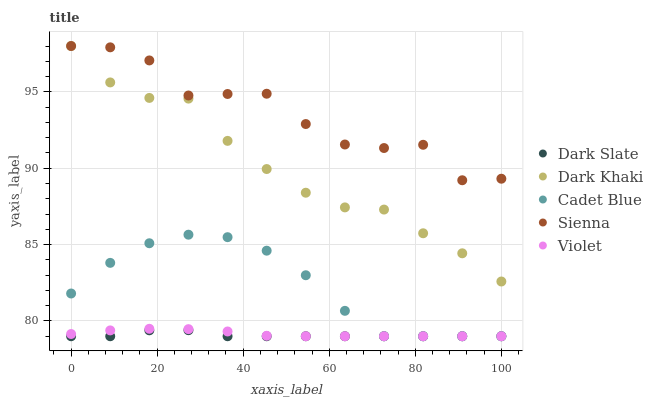Does Dark Slate have the minimum area under the curve?
Answer yes or no. Yes. Does Sienna have the maximum area under the curve?
Answer yes or no. Yes. Does Cadet Blue have the minimum area under the curve?
Answer yes or no. No. Does Cadet Blue have the maximum area under the curve?
Answer yes or no. No. Is Violet the smoothest?
Answer yes or no. Yes. Is Sienna the roughest?
Answer yes or no. Yes. Is Dark Slate the smoothest?
Answer yes or no. No. Is Dark Slate the roughest?
Answer yes or no. No. Does Dark Slate have the lowest value?
Answer yes or no. Yes. Does Sienna have the lowest value?
Answer yes or no. No. Does Sienna have the highest value?
Answer yes or no. Yes. Does Cadet Blue have the highest value?
Answer yes or no. No. Is Violet less than Dark Khaki?
Answer yes or no. Yes. Is Dark Khaki greater than Violet?
Answer yes or no. Yes. Does Violet intersect Cadet Blue?
Answer yes or no. Yes. Is Violet less than Cadet Blue?
Answer yes or no. No. Is Violet greater than Cadet Blue?
Answer yes or no. No. Does Violet intersect Dark Khaki?
Answer yes or no. No. 